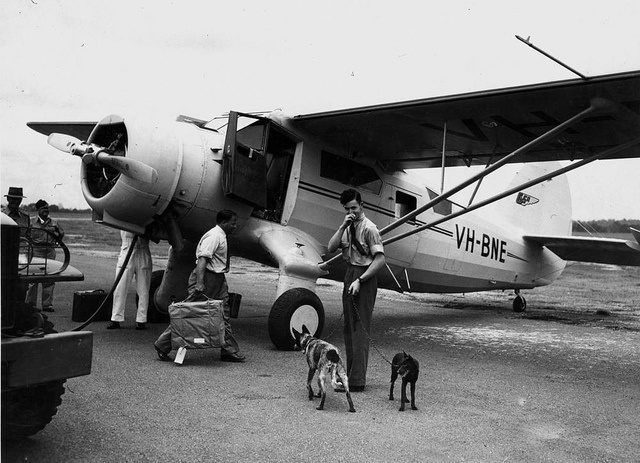Describe the objects in this image and their specific colors. I can see airplane in lightgray, black, gray, and darkgray tones, truck in lightgray, black, gray, and darkgray tones, people in lightgray, black, gray, and darkgray tones, people in lightgray, black, gray, and darkgray tones, and suitcase in lightgray, gray, black, and darkgray tones in this image. 